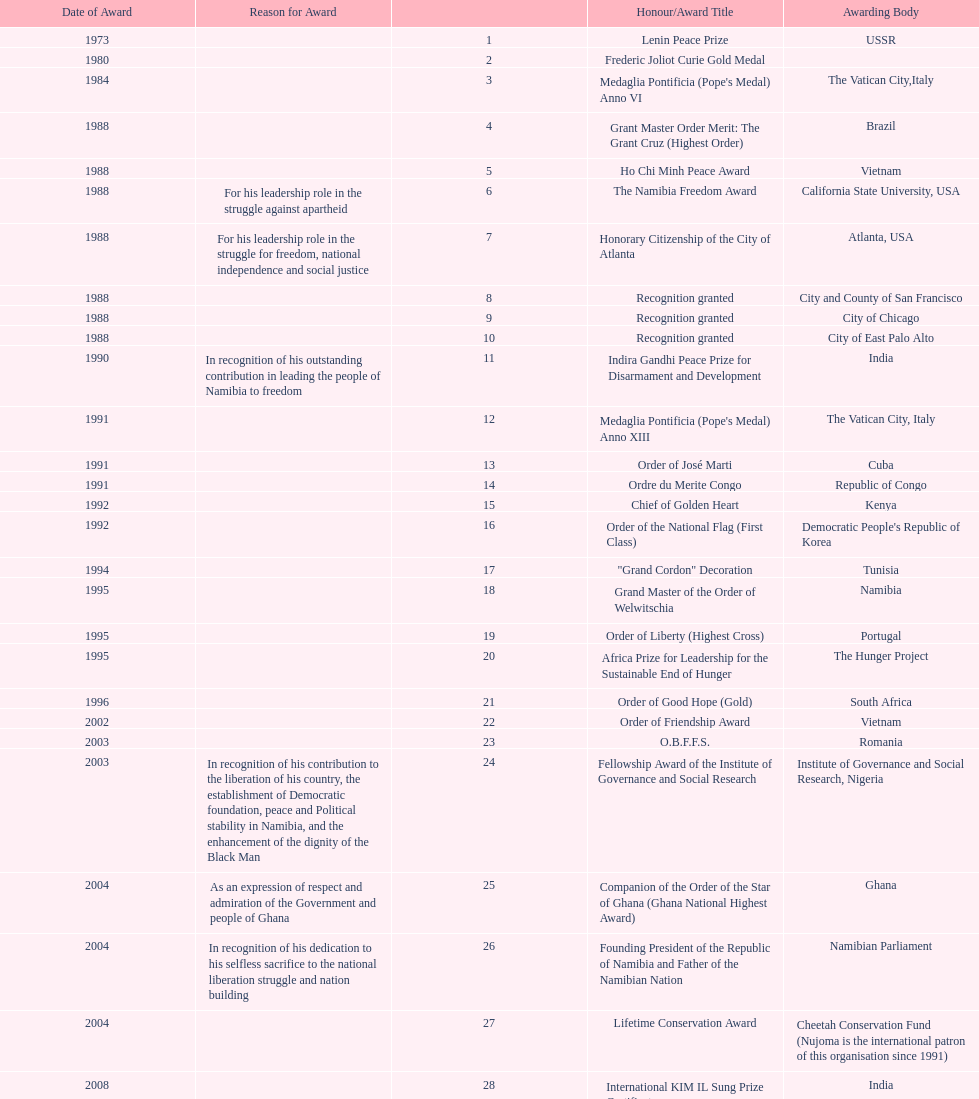What is the most recent award nujoma received? Sir Seretse Khama SADC Meda. 